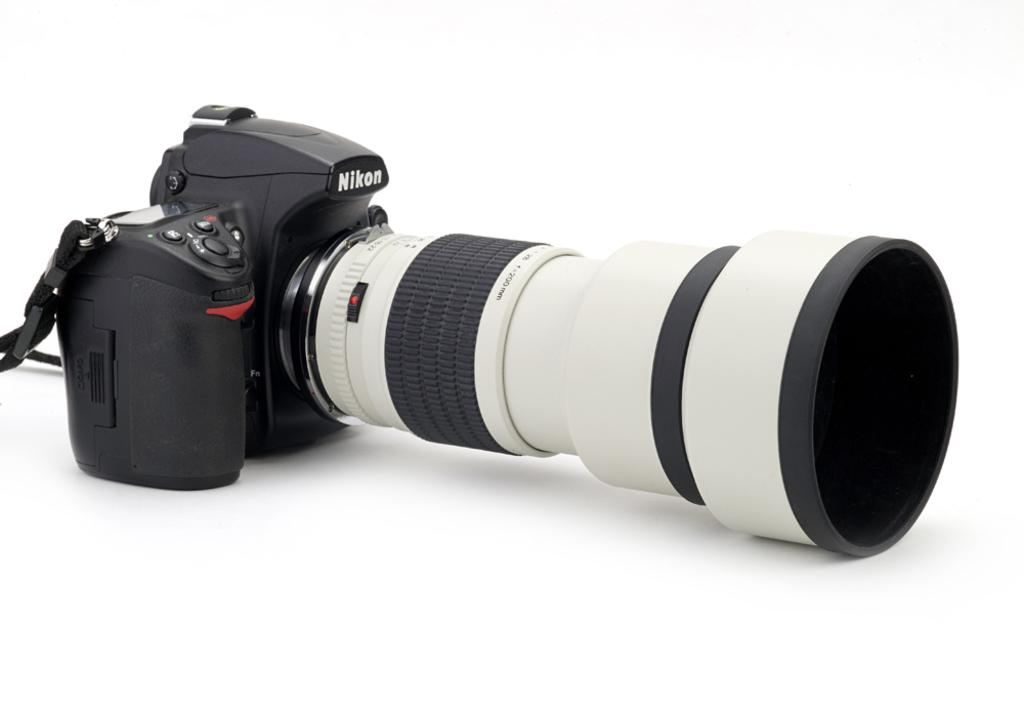What object is the main subject of the image? There is a camera in the image. What color is the background of the image? The background of the image is white. How many snakes are slithering across the camera in the image? There are no snakes present in the image; it features a camera with a white background. What type of clouds can be seen in the image? There are no clouds visible in the image, as the background is white. 